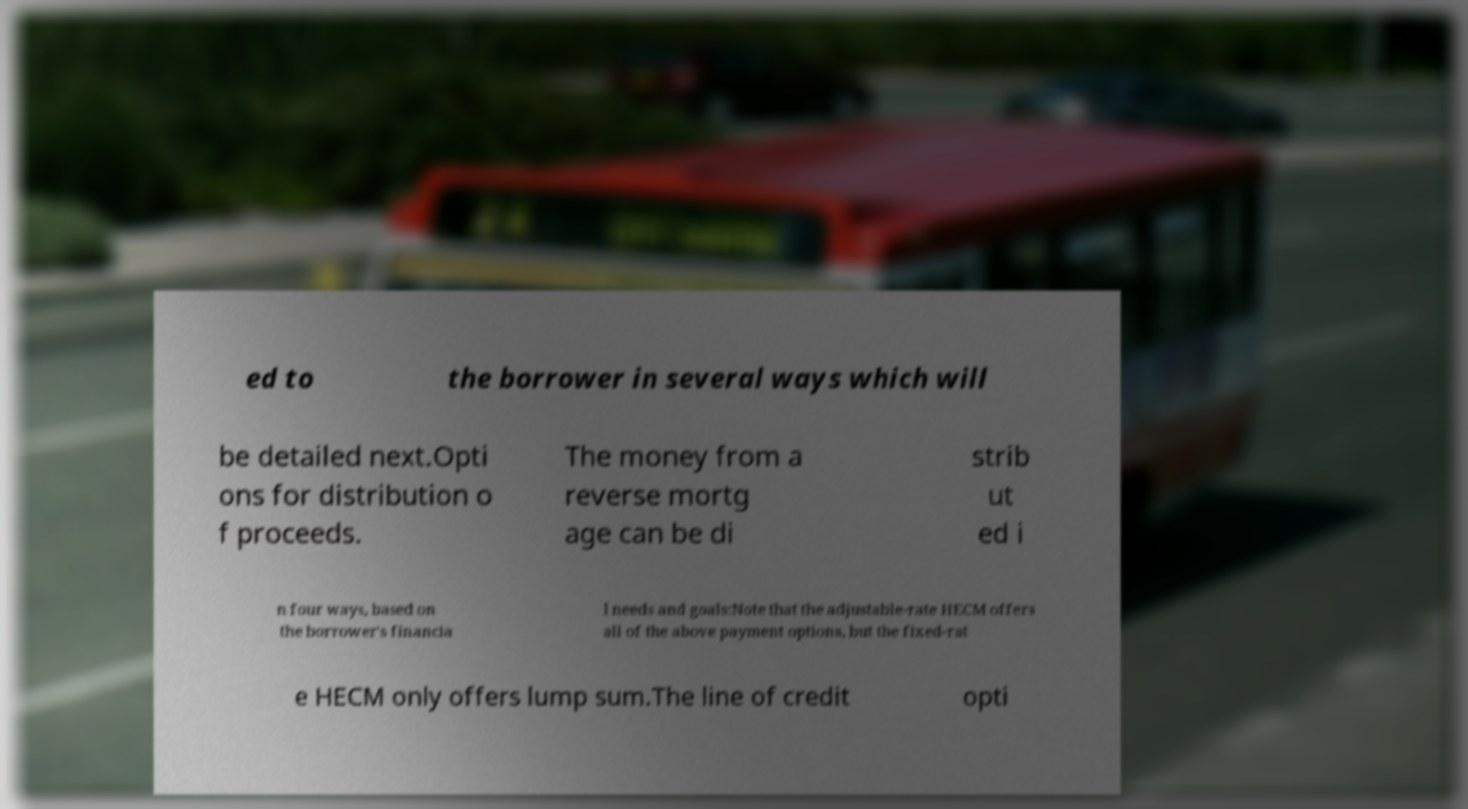There's text embedded in this image that I need extracted. Can you transcribe it verbatim? ed to the borrower in several ways which will be detailed next.Opti ons for distribution o f proceeds. The money from a reverse mortg age can be di strib ut ed i n four ways, based on the borrower's financia l needs and goals:Note that the adjustable-rate HECM offers all of the above payment options, but the fixed-rat e HECM only offers lump sum.The line of credit opti 